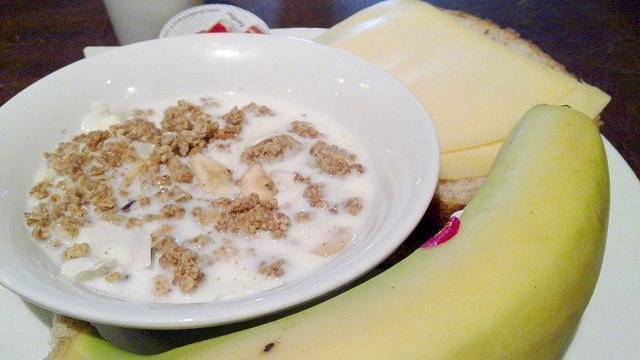How many people wears the blue jersey?
Give a very brief answer. 0. 